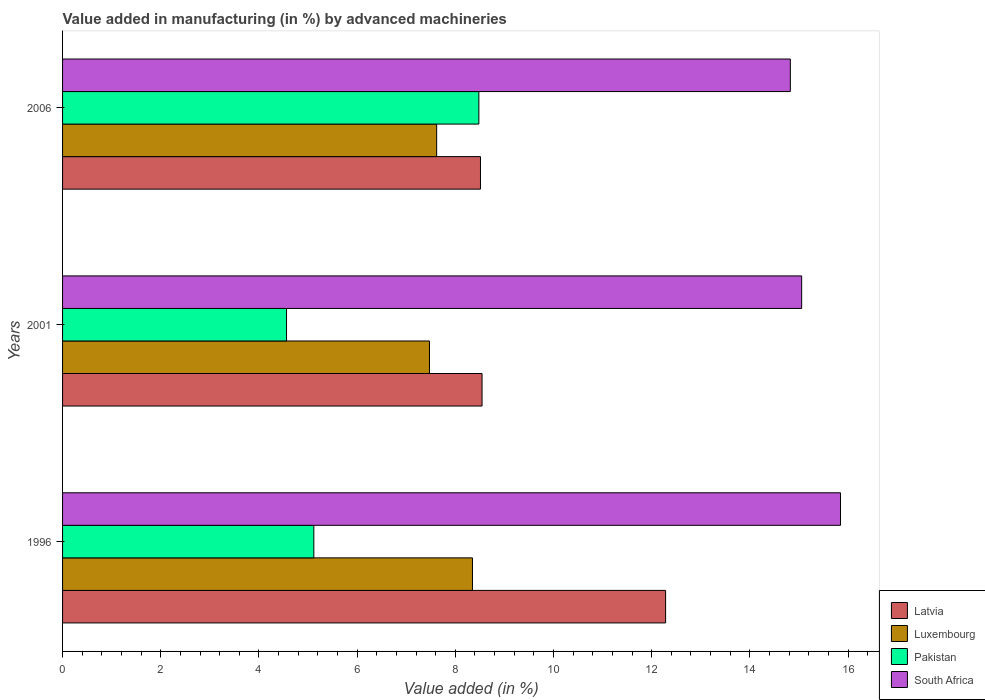How many different coloured bars are there?
Provide a short and direct response. 4. How many groups of bars are there?
Your answer should be very brief. 3. Are the number of bars on each tick of the Y-axis equal?
Provide a short and direct response. Yes. How many bars are there on the 2nd tick from the top?
Your answer should be compact. 4. What is the label of the 2nd group of bars from the top?
Offer a terse response. 2001. What is the percentage of value added in manufacturing by advanced machineries in Pakistan in 2001?
Keep it short and to the point. 4.56. Across all years, what is the maximum percentage of value added in manufacturing by advanced machineries in Latvia?
Ensure brevity in your answer.  12.28. Across all years, what is the minimum percentage of value added in manufacturing by advanced machineries in Pakistan?
Ensure brevity in your answer.  4.56. What is the total percentage of value added in manufacturing by advanced machineries in South Africa in the graph?
Ensure brevity in your answer.  45.72. What is the difference between the percentage of value added in manufacturing by advanced machineries in Pakistan in 1996 and that in 2001?
Keep it short and to the point. 0.56. What is the difference between the percentage of value added in manufacturing by advanced machineries in South Africa in 2006 and the percentage of value added in manufacturing by advanced machineries in Luxembourg in 2001?
Provide a succinct answer. 7.35. What is the average percentage of value added in manufacturing by advanced machineries in Luxembourg per year?
Your response must be concise. 7.81. In the year 1996, what is the difference between the percentage of value added in manufacturing by advanced machineries in Pakistan and percentage of value added in manufacturing by advanced machineries in South Africa?
Offer a very short reply. -10.73. What is the ratio of the percentage of value added in manufacturing by advanced machineries in Pakistan in 1996 to that in 2006?
Offer a terse response. 0.6. What is the difference between the highest and the second highest percentage of value added in manufacturing by advanced machineries in South Africa?
Keep it short and to the point. 0.79. What is the difference between the highest and the lowest percentage of value added in manufacturing by advanced machineries in South Africa?
Your answer should be compact. 1.02. Is the sum of the percentage of value added in manufacturing by advanced machineries in Pakistan in 2001 and 2006 greater than the maximum percentage of value added in manufacturing by advanced machineries in South Africa across all years?
Provide a succinct answer. No. Is it the case that in every year, the sum of the percentage of value added in manufacturing by advanced machineries in Luxembourg and percentage of value added in manufacturing by advanced machineries in Latvia is greater than the sum of percentage of value added in manufacturing by advanced machineries in South Africa and percentage of value added in manufacturing by advanced machineries in Pakistan?
Keep it short and to the point. No. What does the 2nd bar from the top in 2001 represents?
Provide a short and direct response. Pakistan. What does the 2nd bar from the bottom in 2006 represents?
Offer a very short reply. Luxembourg. Is it the case that in every year, the sum of the percentage of value added in manufacturing by advanced machineries in Luxembourg and percentage of value added in manufacturing by advanced machineries in Latvia is greater than the percentage of value added in manufacturing by advanced machineries in Pakistan?
Your response must be concise. Yes. Are all the bars in the graph horizontal?
Your response must be concise. Yes. What is the difference between two consecutive major ticks on the X-axis?
Offer a very short reply. 2. Where does the legend appear in the graph?
Your response must be concise. Bottom right. How many legend labels are there?
Your answer should be very brief. 4. How are the legend labels stacked?
Offer a terse response. Vertical. What is the title of the graph?
Your answer should be compact. Value added in manufacturing (in %) by advanced machineries. What is the label or title of the X-axis?
Ensure brevity in your answer.  Value added (in %). What is the Value added (in %) in Latvia in 1996?
Your answer should be compact. 12.28. What is the Value added (in %) of Luxembourg in 1996?
Your answer should be very brief. 8.35. What is the Value added (in %) in Pakistan in 1996?
Ensure brevity in your answer.  5.12. What is the Value added (in %) of South Africa in 1996?
Provide a succinct answer. 15.85. What is the Value added (in %) in Latvia in 2001?
Your answer should be compact. 8.54. What is the Value added (in %) of Luxembourg in 2001?
Your answer should be compact. 7.47. What is the Value added (in %) of Pakistan in 2001?
Provide a short and direct response. 4.56. What is the Value added (in %) of South Africa in 2001?
Provide a short and direct response. 15.05. What is the Value added (in %) in Latvia in 2006?
Keep it short and to the point. 8.51. What is the Value added (in %) in Luxembourg in 2006?
Your answer should be compact. 7.62. What is the Value added (in %) of Pakistan in 2006?
Make the answer very short. 8.48. What is the Value added (in %) of South Africa in 2006?
Provide a succinct answer. 14.82. Across all years, what is the maximum Value added (in %) of Latvia?
Provide a succinct answer. 12.28. Across all years, what is the maximum Value added (in %) in Luxembourg?
Keep it short and to the point. 8.35. Across all years, what is the maximum Value added (in %) in Pakistan?
Offer a terse response. 8.48. Across all years, what is the maximum Value added (in %) of South Africa?
Your answer should be compact. 15.85. Across all years, what is the minimum Value added (in %) in Latvia?
Keep it short and to the point. 8.51. Across all years, what is the minimum Value added (in %) of Luxembourg?
Provide a short and direct response. 7.47. Across all years, what is the minimum Value added (in %) in Pakistan?
Your answer should be very brief. 4.56. Across all years, what is the minimum Value added (in %) of South Africa?
Your answer should be compact. 14.82. What is the total Value added (in %) in Latvia in the graph?
Give a very brief answer. 29.34. What is the total Value added (in %) of Luxembourg in the graph?
Offer a very short reply. 23.44. What is the total Value added (in %) of Pakistan in the graph?
Give a very brief answer. 18.16. What is the total Value added (in %) of South Africa in the graph?
Provide a short and direct response. 45.72. What is the difference between the Value added (in %) of Latvia in 1996 and that in 2001?
Provide a succinct answer. 3.74. What is the difference between the Value added (in %) in Luxembourg in 1996 and that in 2001?
Give a very brief answer. 0.88. What is the difference between the Value added (in %) in Pakistan in 1996 and that in 2001?
Offer a very short reply. 0.56. What is the difference between the Value added (in %) in South Africa in 1996 and that in 2001?
Your answer should be compact. 0.79. What is the difference between the Value added (in %) of Latvia in 1996 and that in 2006?
Keep it short and to the point. 3.77. What is the difference between the Value added (in %) in Luxembourg in 1996 and that in 2006?
Your answer should be compact. 0.73. What is the difference between the Value added (in %) of Pakistan in 1996 and that in 2006?
Your response must be concise. -3.36. What is the difference between the Value added (in %) of South Africa in 1996 and that in 2006?
Provide a succinct answer. 1.02. What is the difference between the Value added (in %) in Latvia in 2001 and that in 2006?
Give a very brief answer. 0.03. What is the difference between the Value added (in %) of Luxembourg in 2001 and that in 2006?
Provide a succinct answer. -0.15. What is the difference between the Value added (in %) of Pakistan in 2001 and that in 2006?
Provide a succinct answer. -3.92. What is the difference between the Value added (in %) of South Africa in 2001 and that in 2006?
Keep it short and to the point. 0.23. What is the difference between the Value added (in %) in Latvia in 1996 and the Value added (in %) in Luxembourg in 2001?
Your answer should be very brief. 4.81. What is the difference between the Value added (in %) in Latvia in 1996 and the Value added (in %) in Pakistan in 2001?
Keep it short and to the point. 7.72. What is the difference between the Value added (in %) in Latvia in 1996 and the Value added (in %) in South Africa in 2001?
Keep it short and to the point. -2.77. What is the difference between the Value added (in %) of Luxembourg in 1996 and the Value added (in %) of Pakistan in 2001?
Ensure brevity in your answer.  3.79. What is the difference between the Value added (in %) of Luxembourg in 1996 and the Value added (in %) of South Africa in 2001?
Ensure brevity in your answer.  -6.71. What is the difference between the Value added (in %) of Pakistan in 1996 and the Value added (in %) of South Africa in 2001?
Your response must be concise. -9.94. What is the difference between the Value added (in %) in Latvia in 1996 and the Value added (in %) in Luxembourg in 2006?
Give a very brief answer. 4.66. What is the difference between the Value added (in %) in Latvia in 1996 and the Value added (in %) in Pakistan in 2006?
Your answer should be very brief. 3.8. What is the difference between the Value added (in %) of Latvia in 1996 and the Value added (in %) of South Africa in 2006?
Ensure brevity in your answer.  -2.54. What is the difference between the Value added (in %) of Luxembourg in 1996 and the Value added (in %) of Pakistan in 2006?
Ensure brevity in your answer.  -0.13. What is the difference between the Value added (in %) of Luxembourg in 1996 and the Value added (in %) of South Africa in 2006?
Give a very brief answer. -6.47. What is the difference between the Value added (in %) in Pakistan in 1996 and the Value added (in %) in South Africa in 2006?
Ensure brevity in your answer.  -9.71. What is the difference between the Value added (in %) of Latvia in 2001 and the Value added (in %) of Luxembourg in 2006?
Provide a succinct answer. 0.92. What is the difference between the Value added (in %) of Latvia in 2001 and the Value added (in %) of Pakistan in 2006?
Provide a short and direct response. 0.06. What is the difference between the Value added (in %) in Latvia in 2001 and the Value added (in %) in South Africa in 2006?
Offer a very short reply. -6.28. What is the difference between the Value added (in %) in Luxembourg in 2001 and the Value added (in %) in Pakistan in 2006?
Provide a succinct answer. -1.01. What is the difference between the Value added (in %) in Luxembourg in 2001 and the Value added (in %) in South Africa in 2006?
Make the answer very short. -7.35. What is the difference between the Value added (in %) in Pakistan in 2001 and the Value added (in %) in South Africa in 2006?
Provide a short and direct response. -10.26. What is the average Value added (in %) of Latvia per year?
Offer a very short reply. 9.78. What is the average Value added (in %) in Luxembourg per year?
Your response must be concise. 7.81. What is the average Value added (in %) in Pakistan per year?
Your answer should be compact. 6.05. What is the average Value added (in %) in South Africa per year?
Provide a succinct answer. 15.24. In the year 1996, what is the difference between the Value added (in %) of Latvia and Value added (in %) of Luxembourg?
Provide a short and direct response. 3.93. In the year 1996, what is the difference between the Value added (in %) in Latvia and Value added (in %) in Pakistan?
Give a very brief answer. 7.17. In the year 1996, what is the difference between the Value added (in %) in Latvia and Value added (in %) in South Africa?
Make the answer very short. -3.56. In the year 1996, what is the difference between the Value added (in %) of Luxembourg and Value added (in %) of Pakistan?
Give a very brief answer. 3.23. In the year 1996, what is the difference between the Value added (in %) in Luxembourg and Value added (in %) in South Africa?
Your answer should be very brief. -7.5. In the year 1996, what is the difference between the Value added (in %) in Pakistan and Value added (in %) in South Africa?
Provide a short and direct response. -10.73. In the year 2001, what is the difference between the Value added (in %) in Latvia and Value added (in %) in Luxembourg?
Give a very brief answer. 1.07. In the year 2001, what is the difference between the Value added (in %) in Latvia and Value added (in %) in Pakistan?
Make the answer very short. 3.98. In the year 2001, what is the difference between the Value added (in %) of Latvia and Value added (in %) of South Africa?
Keep it short and to the point. -6.51. In the year 2001, what is the difference between the Value added (in %) in Luxembourg and Value added (in %) in Pakistan?
Offer a terse response. 2.91. In the year 2001, what is the difference between the Value added (in %) in Luxembourg and Value added (in %) in South Africa?
Provide a short and direct response. -7.58. In the year 2001, what is the difference between the Value added (in %) in Pakistan and Value added (in %) in South Africa?
Offer a very short reply. -10.49. In the year 2006, what is the difference between the Value added (in %) in Latvia and Value added (in %) in Luxembourg?
Your answer should be compact. 0.89. In the year 2006, what is the difference between the Value added (in %) of Latvia and Value added (in %) of Pakistan?
Provide a succinct answer. 0.03. In the year 2006, what is the difference between the Value added (in %) of Latvia and Value added (in %) of South Africa?
Your answer should be compact. -6.31. In the year 2006, what is the difference between the Value added (in %) in Luxembourg and Value added (in %) in Pakistan?
Make the answer very short. -0.86. In the year 2006, what is the difference between the Value added (in %) in Luxembourg and Value added (in %) in South Africa?
Give a very brief answer. -7.2. In the year 2006, what is the difference between the Value added (in %) in Pakistan and Value added (in %) in South Africa?
Give a very brief answer. -6.34. What is the ratio of the Value added (in %) in Latvia in 1996 to that in 2001?
Offer a very short reply. 1.44. What is the ratio of the Value added (in %) in Luxembourg in 1996 to that in 2001?
Your answer should be very brief. 1.12. What is the ratio of the Value added (in %) in Pakistan in 1996 to that in 2001?
Your response must be concise. 1.12. What is the ratio of the Value added (in %) in South Africa in 1996 to that in 2001?
Provide a short and direct response. 1.05. What is the ratio of the Value added (in %) of Latvia in 1996 to that in 2006?
Make the answer very short. 1.44. What is the ratio of the Value added (in %) in Luxembourg in 1996 to that in 2006?
Offer a very short reply. 1.1. What is the ratio of the Value added (in %) of Pakistan in 1996 to that in 2006?
Your response must be concise. 0.6. What is the ratio of the Value added (in %) in South Africa in 1996 to that in 2006?
Provide a succinct answer. 1.07. What is the ratio of the Value added (in %) in Luxembourg in 2001 to that in 2006?
Give a very brief answer. 0.98. What is the ratio of the Value added (in %) of Pakistan in 2001 to that in 2006?
Keep it short and to the point. 0.54. What is the ratio of the Value added (in %) of South Africa in 2001 to that in 2006?
Ensure brevity in your answer.  1.02. What is the difference between the highest and the second highest Value added (in %) in Latvia?
Your answer should be very brief. 3.74. What is the difference between the highest and the second highest Value added (in %) of Luxembourg?
Provide a succinct answer. 0.73. What is the difference between the highest and the second highest Value added (in %) in Pakistan?
Offer a very short reply. 3.36. What is the difference between the highest and the second highest Value added (in %) in South Africa?
Offer a terse response. 0.79. What is the difference between the highest and the lowest Value added (in %) in Latvia?
Give a very brief answer. 3.77. What is the difference between the highest and the lowest Value added (in %) in Luxembourg?
Your answer should be very brief. 0.88. What is the difference between the highest and the lowest Value added (in %) in Pakistan?
Your answer should be compact. 3.92. What is the difference between the highest and the lowest Value added (in %) in South Africa?
Offer a terse response. 1.02. 